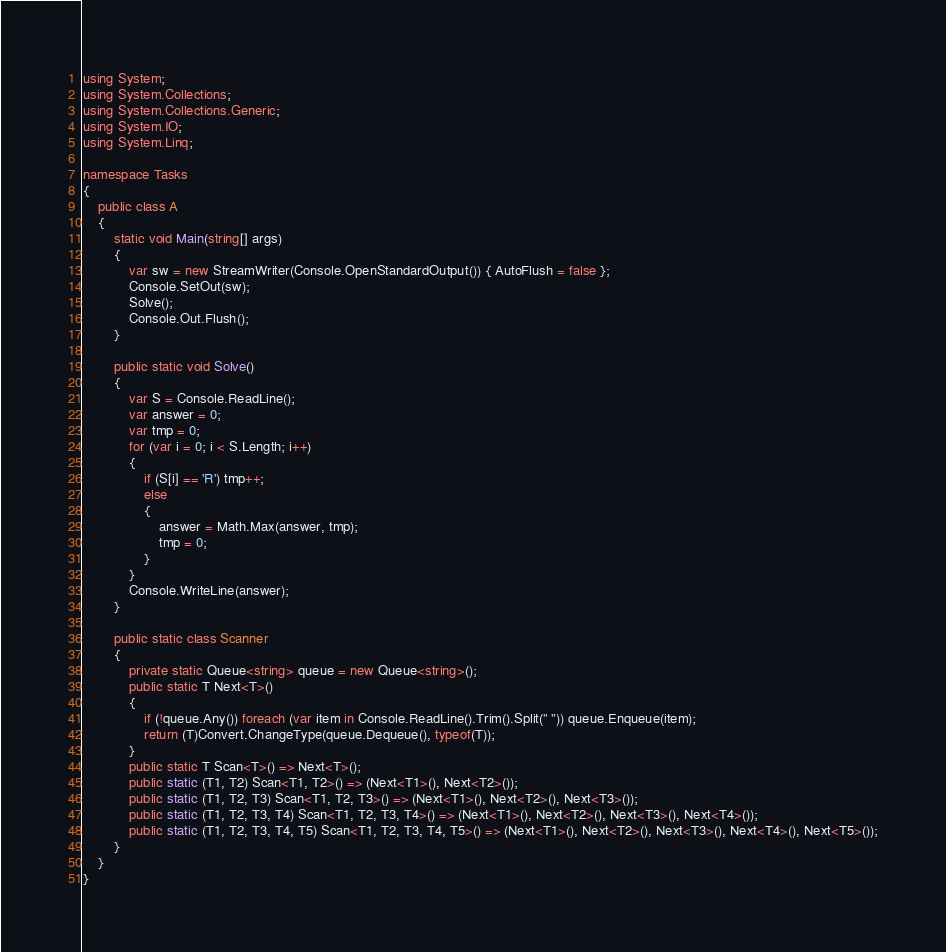<code> <loc_0><loc_0><loc_500><loc_500><_C#_>using System;
using System.Collections;
using System.Collections.Generic;
using System.IO;
using System.Linq;

namespace Tasks
{
    public class A
    {
        static void Main(string[] args)
        {
            var sw = new StreamWriter(Console.OpenStandardOutput()) { AutoFlush = false };
            Console.SetOut(sw);
            Solve();
            Console.Out.Flush();
        }

        public static void Solve()
        {
            var S = Console.ReadLine();
            var answer = 0;
            var tmp = 0;
            for (var i = 0; i < S.Length; i++)
            {
                if (S[i] == 'R') tmp++;
                else
                {
                    answer = Math.Max(answer, tmp);
                    tmp = 0;
                }
            }
            Console.WriteLine(answer);
        }

        public static class Scanner
        {
            private static Queue<string> queue = new Queue<string>();
            public static T Next<T>()
            {
                if (!queue.Any()) foreach (var item in Console.ReadLine().Trim().Split(" ")) queue.Enqueue(item);
                return (T)Convert.ChangeType(queue.Dequeue(), typeof(T));
            }
            public static T Scan<T>() => Next<T>();
            public static (T1, T2) Scan<T1, T2>() => (Next<T1>(), Next<T2>());
            public static (T1, T2, T3) Scan<T1, T2, T3>() => (Next<T1>(), Next<T2>(), Next<T3>());
            public static (T1, T2, T3, T4) Scan<T1, T2, T3, T4>() => (Next<T1>(), Next<T2>(), Next<T3>(), Next<T4>());
            public static (T1, T2, T3, T4, T5) Scan<T1, T2, T3, T4, T5>() => (Next<T1>(), Next<T2>(), Next<T3>(), Next<T4>(), Next<T5>());
        }
    }
}
</code> 